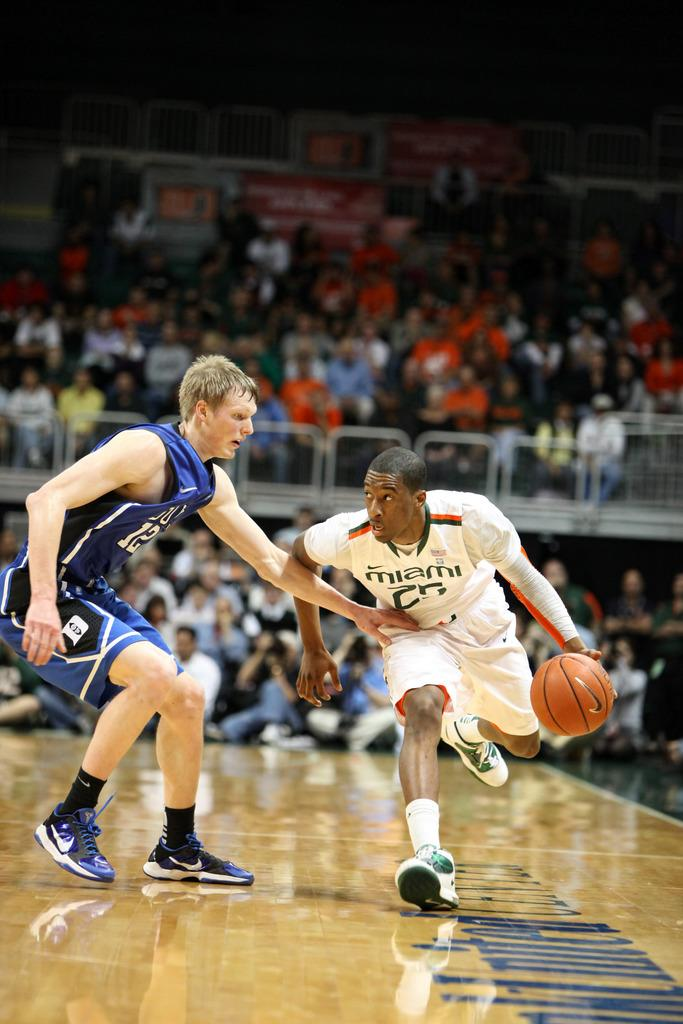How many basketball players are in the image? There are two basketball players in the image. What are the basketball players doing in the image? The basketball players are playing a game. Are there any other people present in the image besides the basketball players? Yes, there are spectators in the image. What page of the book is the basketball player reading during the game? There is no book present in the image, and the basketball players are not reading during the game. 